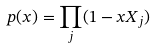<formula> <loc_0><loc_0><loc_500><loc_500>p ( x ) = \prod _ { j } ( 1 - x X _ { j } )</formula> 